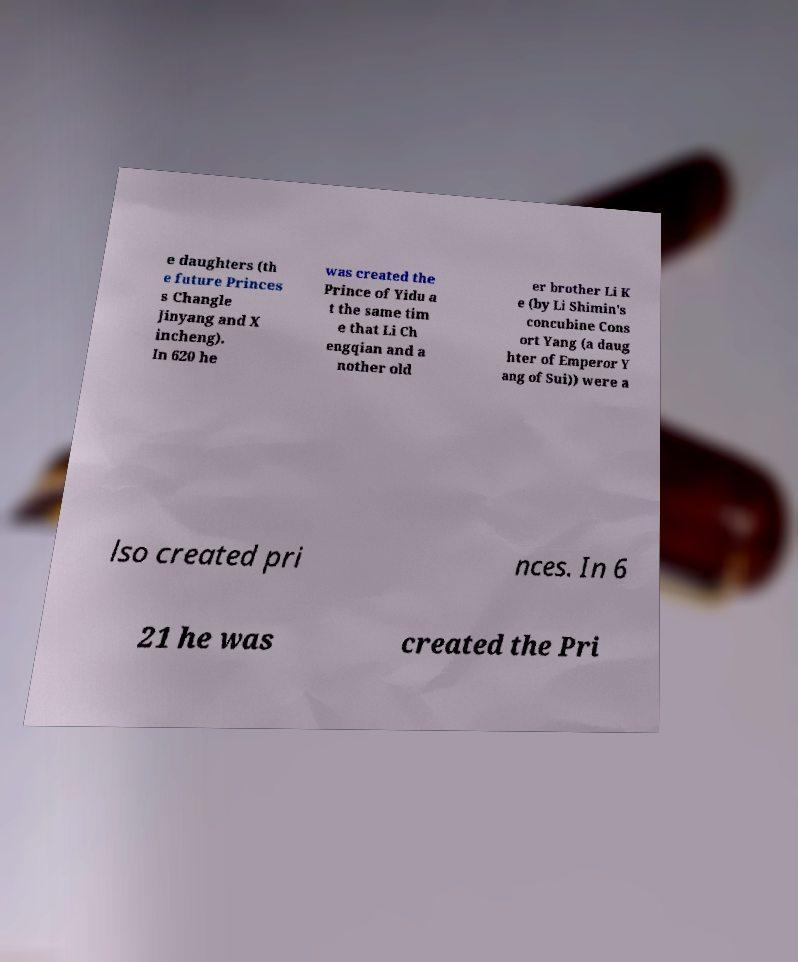Please identify and transcribe the text found in this image. e daughters (th e future Princes s Changle Jinyang and X incheng). In 620 he was created the Prince of Yidu a t the same tim e that Li Ch engqian and a nother old er brother Li K e (by Li Shimin's concubine Cons ort Yang (a daug hter of Emperor Y ang of Sui)) were a lso created pri nces. In 6 21 he was created the Pri 